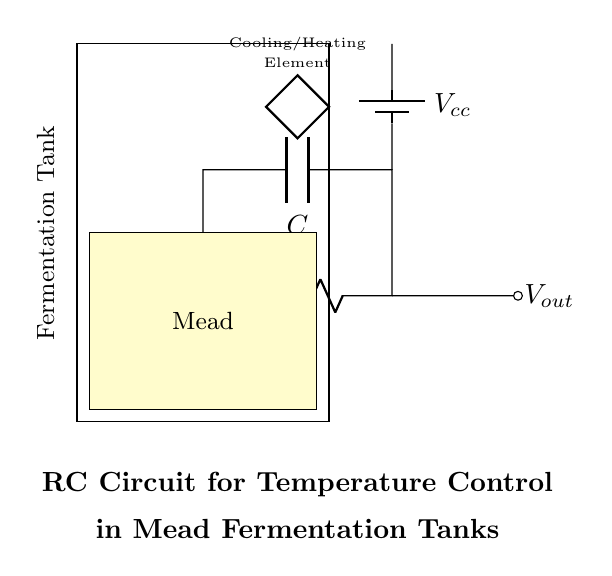What is the component labeled R? R represents a resistor in the circuit, which is used to control the current flow.
Answer: Resistor What does the capacitor C do in this circuit? The capacitor stores and releases energy, which helps stabilize the voltage and filters out noise in the temperature control system.
Answer: Stabilizes voltage What is the function of the temperature sensor? The temperature sensor detects the fermentation temperature of the mead and provides feedback to the circuit to regulate heating or cooling.
Answer: Detects temperature What is the output voltage labeled as? The output voltage is labeled as Vout and is taken from the connection at the right side of the resistor in the circuit.
Answer: Vout How does the resistor and capacitor affect the circuit's response time? The resistor and capacitor together form an RC time constant that determines how quickly the circuit responds to changes in temperature; a larger resistance or capacitance results in a slower response.
Answer: Slower response What could happen if the temperature sensor fails? If the temperature sensor fails, the circuit would not receive accurate temperature readings, potentially leading to improper heating or cooling of the mead.
Answer: Improper temperature control Why is there a battery in the circuit? The battery provides the necessary voltage, Vcc, to power the entire RC circuit, enabling it to function correctly.
Answer: Power supply 